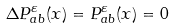<formula> <loc_0><loc_0><loc_500><loc_500>\Delta P _ { a b } ^ { \varepsilon } ( x ) = P _ { a b } ^ { \varepsilon } ( x ) = 0</formula> 